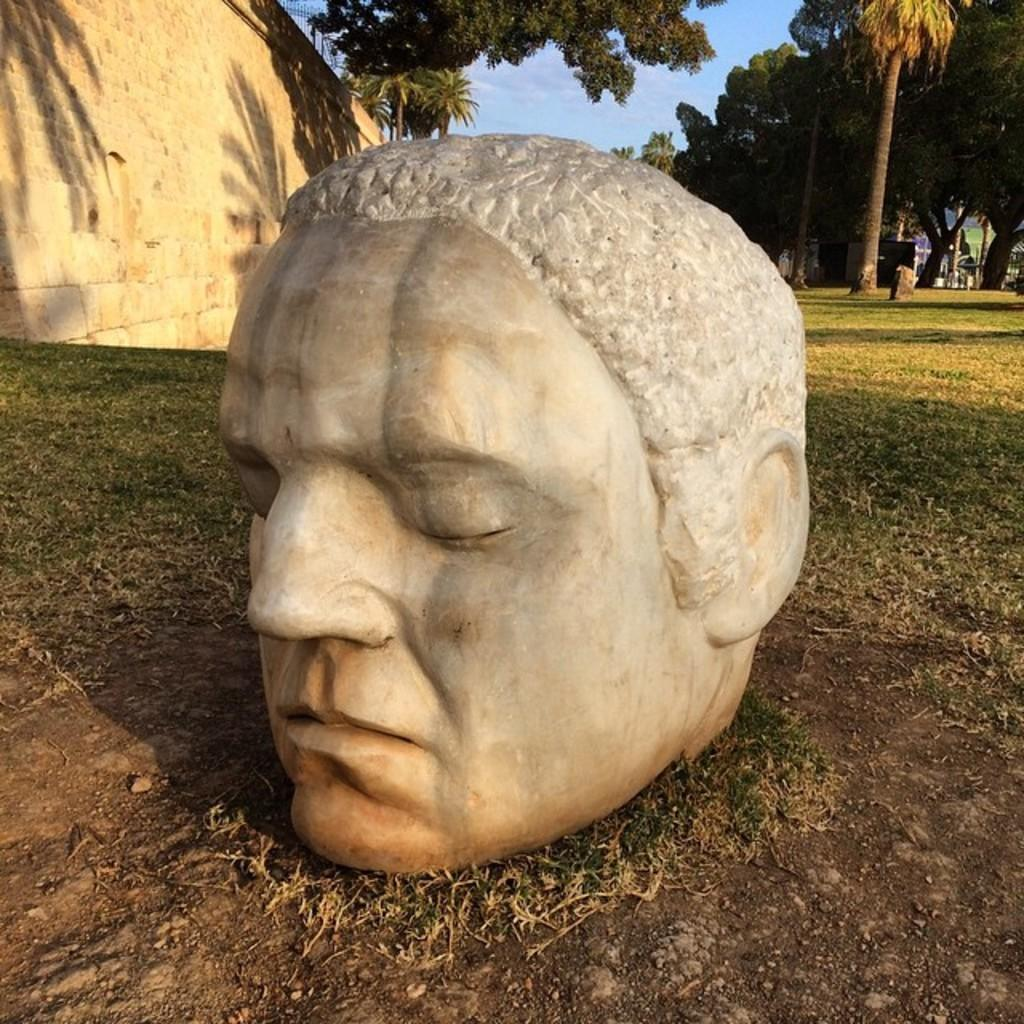What is the main subject of the image? There is a depiction of a person on the ground in the center of the image. What can be seen in the background of the image? There are trees in the background of the image. What is located on the left side of the image? There is a wall on the left side of the image. What type of medical advice is the doctor giving to the person in the image? There is no doctor present in the image, so it is not possible to determine what medical advice might be given. 